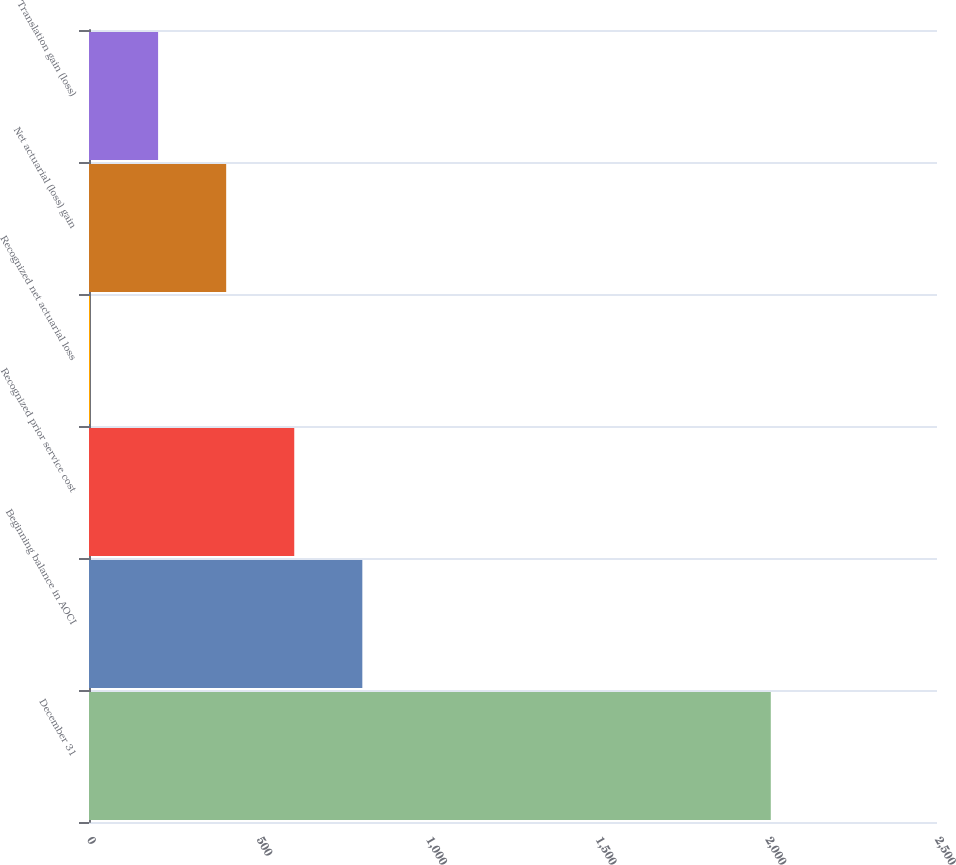Convert chart. <chart><loc_0><loc_0><loc_500><loc_500><bar_chart><fcel>December 31<fcel>Beginning balance in AOCI<fcel>Recognized prior service cost<fcel>Recognized net actuarial loss<fcel>Net actuarial (loss) gain<fcel>Translation gain (loss)<nl><fcel>2010<fcel>805.8<fcel>605.1<fcel>3<fcel>404.4<fcel>203.7<nl></chart> 